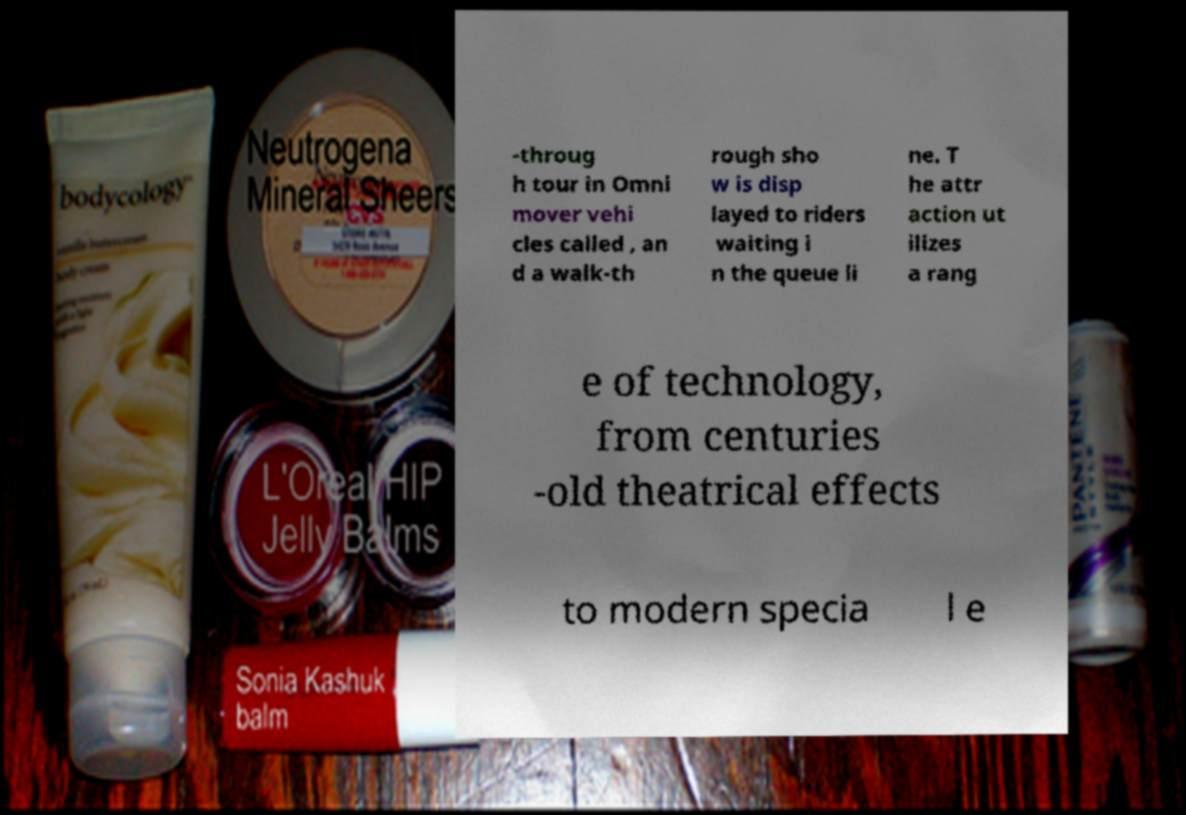What messages or text are displayed in this image? I need them in a readable, typed format. -throug h tour in Omni mover vehi cles called , an d a walk-th rough sho w is disp layed to riders waiting i n the queue li ne. T he attr action ut ilizes a rang e of technology, from centuries -old theatrical effects to modern specia l e 